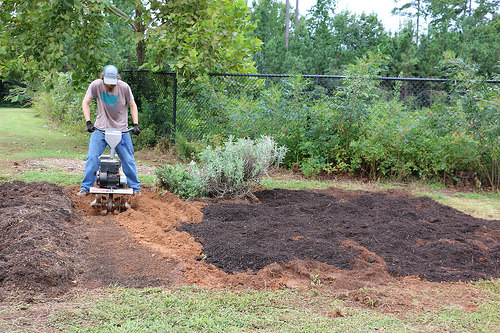<image>
Can you confirm if the fence is in front of the hat? No. The fence is not in front of the hat. The spatial positioning shows a different relationship between these objects. 